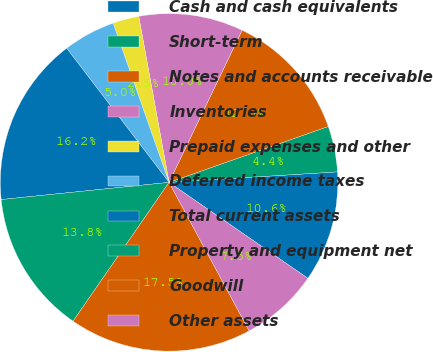Convert chart. <chart><loc_0><loc_0><loc_500><loc_500><pie_chart><fcel>Cash and cash equivalents<fcel>Short-term<fcel>Notes and accounts receivable<fcel>Inventories<fcel>Prepaid expenses and other<fcel>Deferred income taxes<fcel>Total current assets<fcel>Property and equipment net<fcel>Goodwill<fcel>Other assets<nl><fcel>10.62%<fcel>4.38%<fcel>12.5%<fcel>10.0%<fcel>2.5%<fcel>5.0%<fcel>16.25%<fcel>13.75%<fcel>17.5%<fcel>7.5%<nl></chart> 